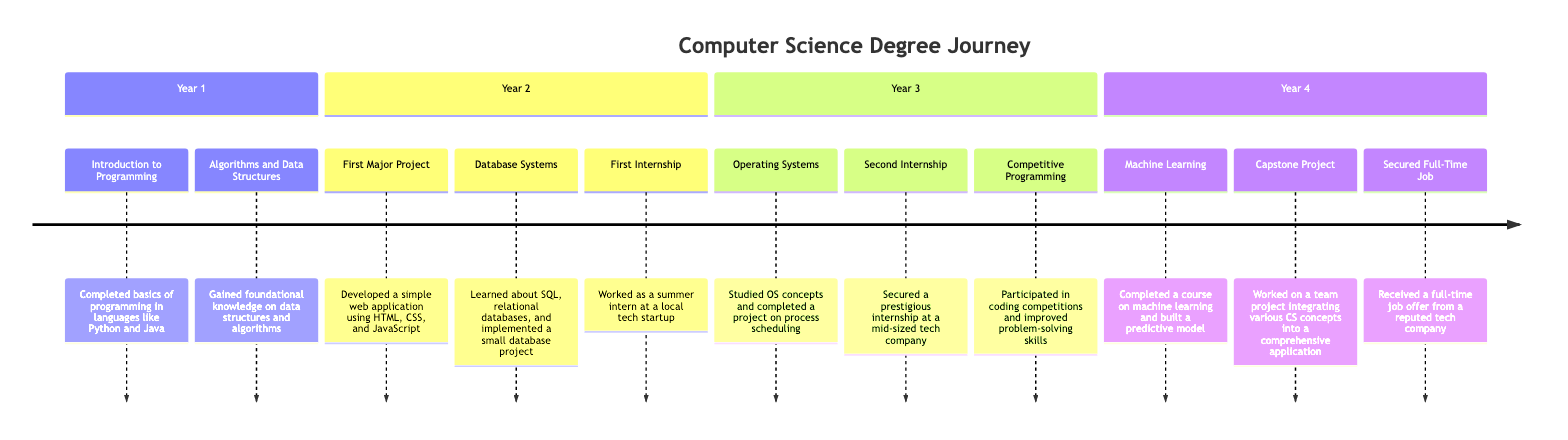What is the first major project completed? The diagram shows that the first major project was "Developed a simple web application using HTML, CSS, and JavaScript" in Year 2.
Answer: Developed a simple web application using HTML, CSS, and JavaScript How many internships did you secure during the degree? By examining the diagram, it lists two internships: the first internship in Year 2 and the second internship in Year 3. Hence, there are two internships noted.
Answer: 2 What year did you complete the course on Machine Learning? The timeline specifies that the Machine Learning course was completed in Year 4, as indicated in the "Year 4" section of the diagram.
Answer: Year 4 Which event marks the conclusion of the timeline? According to the diagram, the last event listed is "Received a full-time job offer from a reputed tech company" in Year 4, marking the end of the educational journey.
Answer: Received a full-time job offer from a reputed tech company What is the relationship between "Capstone Project" and "Machine Learning"? Both "Capstone Project" and "Machine Learning" are events listed under Year 4, indicating they are part of the same year but represent different achievements in that year.
Answer: Part of Year 4 Which milestone emphasizes real-world experience? The "First Internship" and "Second Internship" both focus on gaining real-world experience through work placements, noted in Year 2 and Year 3, respectively.
Answer: First Internship, Second Internship In which year did you begin learning about algorithms? The diagram specifies that foundational knowledge of data structures and algorithms was gained in Year 1, indicating that learning about algorithms began that early in the program.
Answer: Year 1 How many events are noted in Year 3? The timeline displays three events in Year 3: "Operating Systems," "Second Internship," and "Competitive Programming," resulting in a count of three events for that year.
Answer: 3 